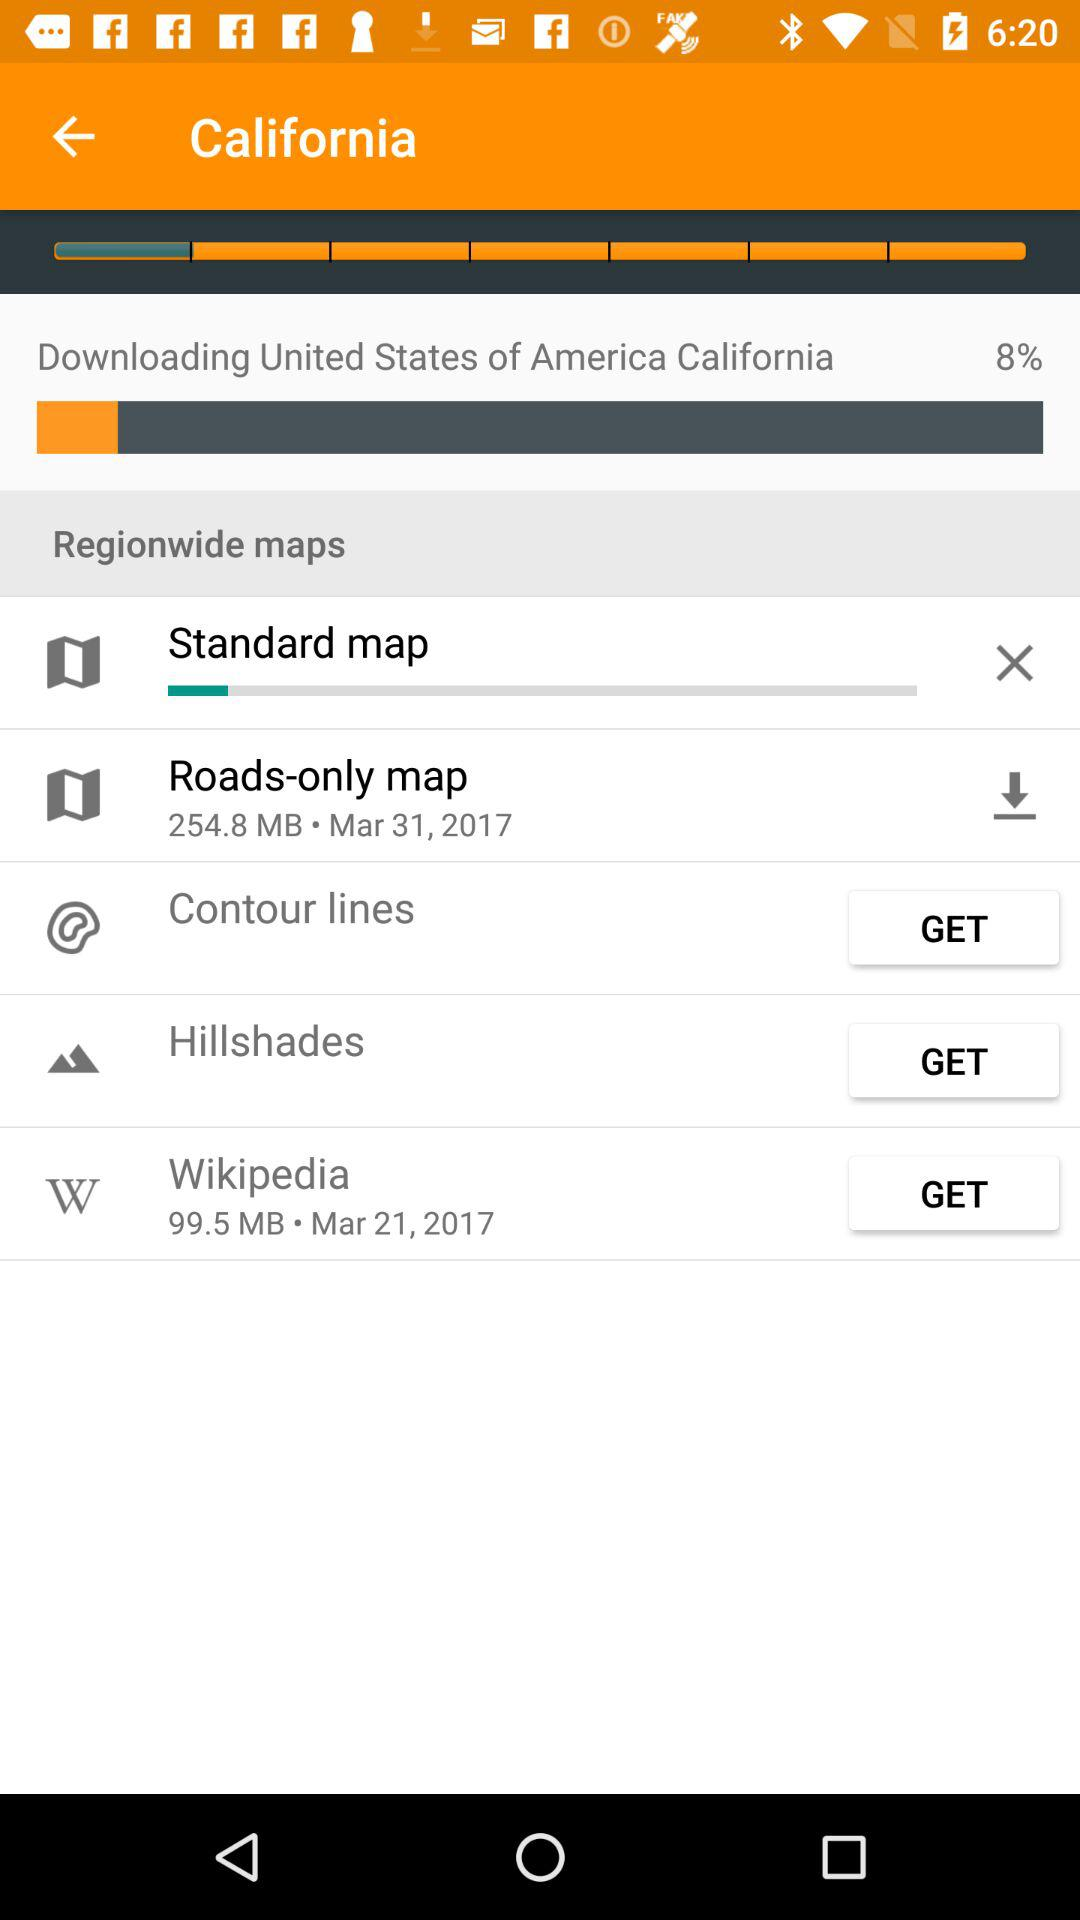How much of it has been downloaded?
When the provided information is insufficient, respond with <no answer>. <no answer> 